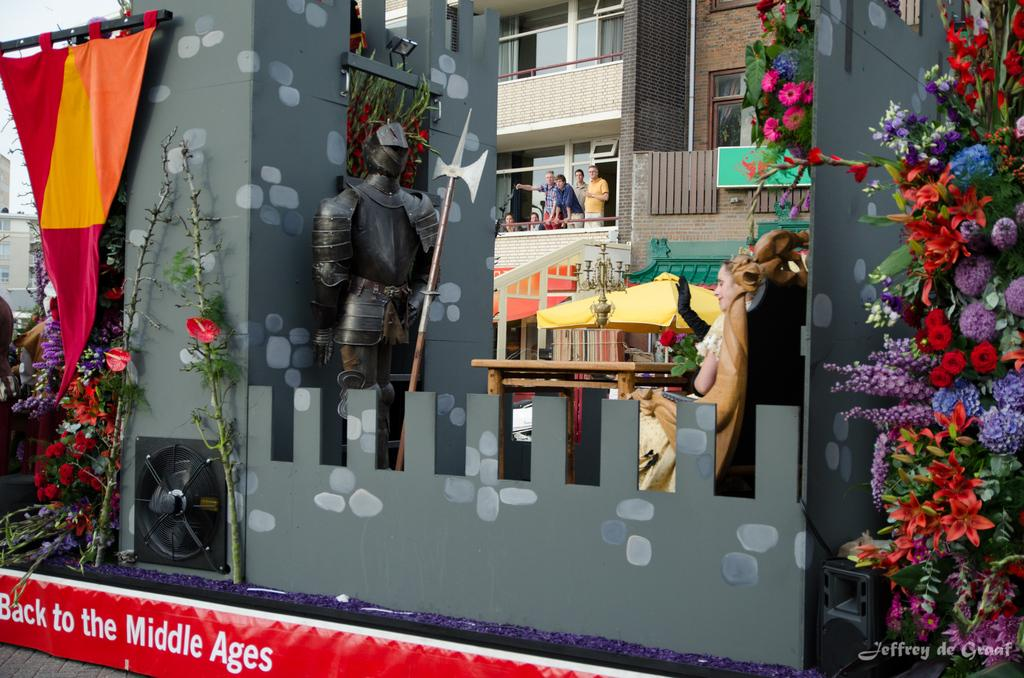<image>
Render a clear and concise summary of the photo. A model of a castle and the words Back to the Middle Ages along the bottom. 